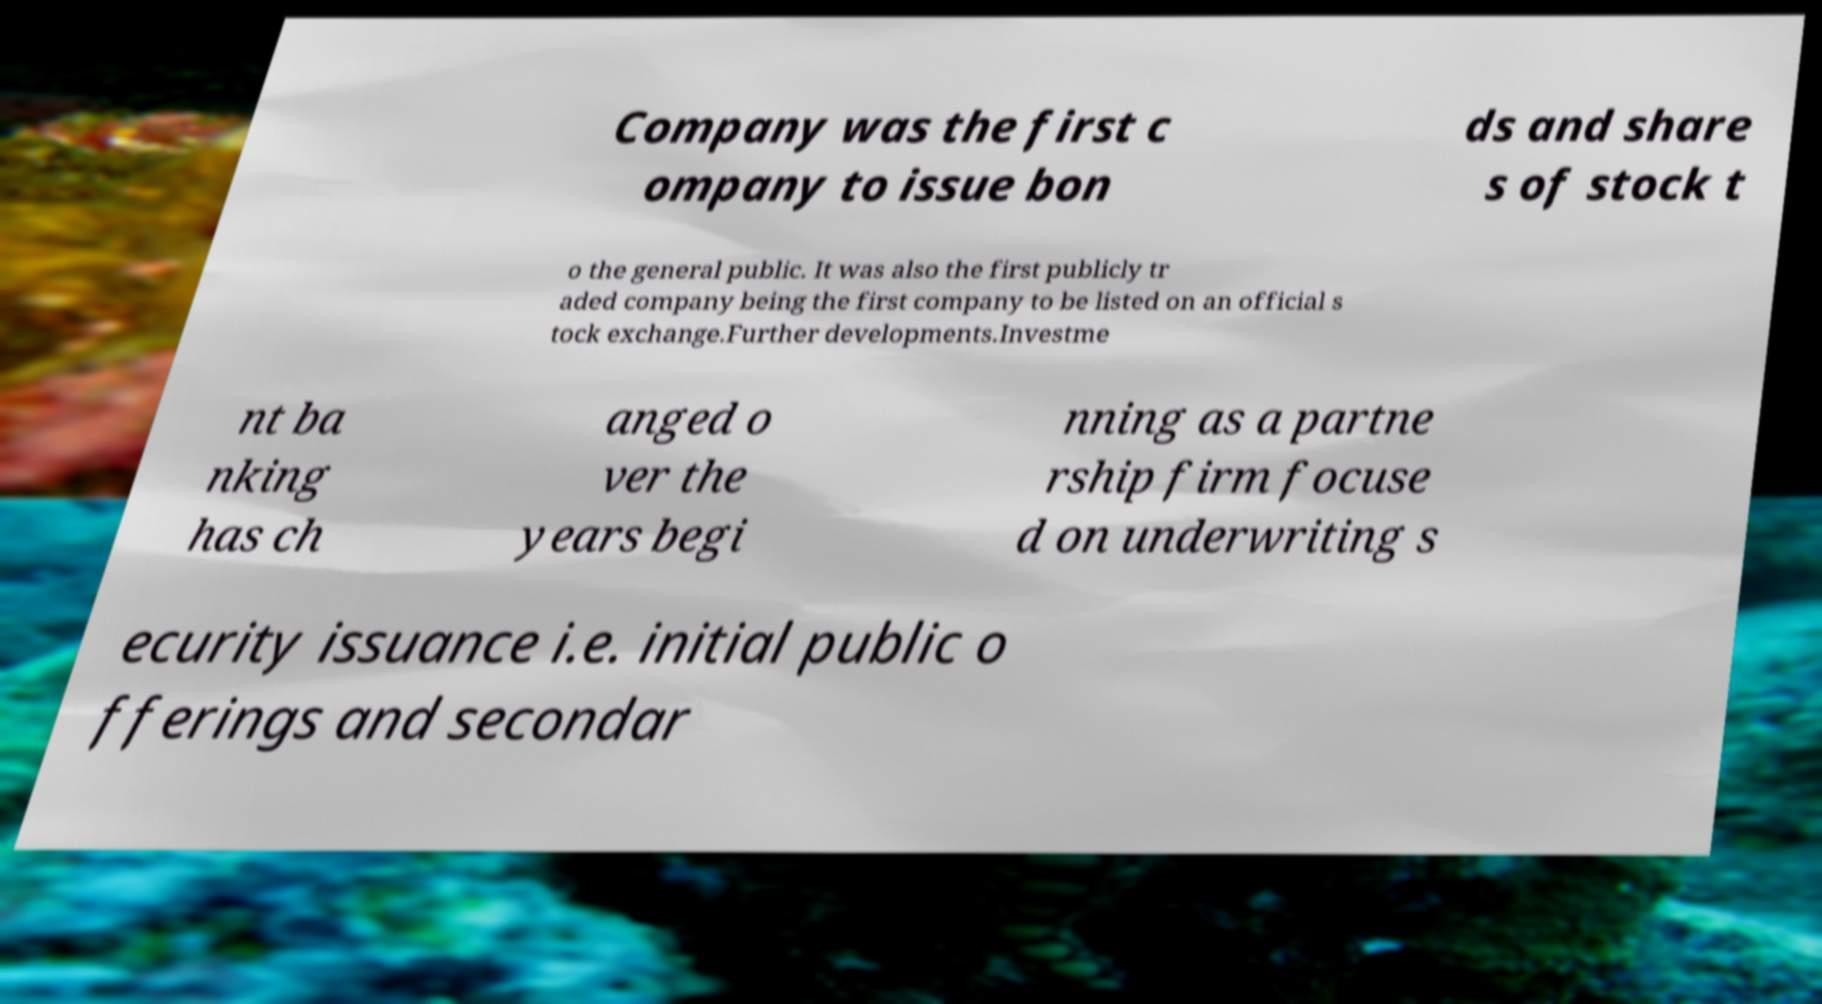What messages or text are displayed in this image? I need them in a readable, typed format. Company was the first c ompany to issue bon ds and share s of stock t o the general public. It was also the first publicly tr aded company being the first company to be listed on an official s tock exchange.Further developments.Investme nt ba nking has ch anged o ver the years begi nning as a partne rship firm focuse d on underwriting s ecurity issuance i.e. initial public o fferings and secondar 